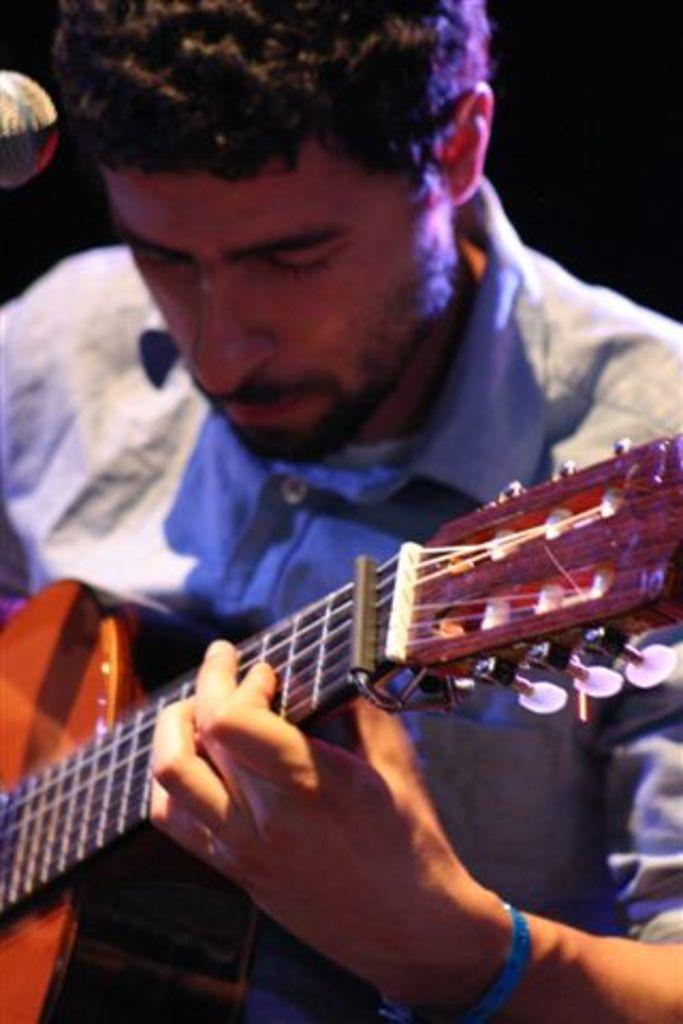What is the man in the image doing? The man is playing a guitar in the image. What object is visible near the man? There is a microphone visible in the image. What type of pear is the man holding in the image? There is no pear present in the image; the man is playing a guitar. How many feet can be seen in the image? The image only shows a man playing a guitar and a microphone, so no feet are visible. 